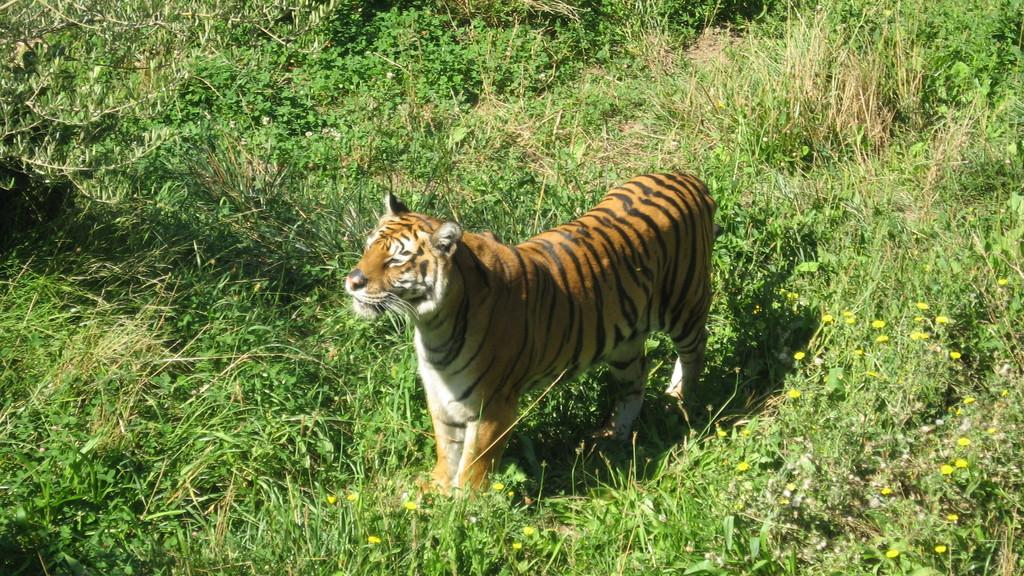What type of animal is in the image? There is a tiger in the image. Where is the tiger located? The tiger is in the grass. What other natural elements can be seen in the image? There are flowers and plants in the image. What type of hole can be seen in the image? There is no hole present in the image. Can you see any smoke coming from the tiger in the image? No, there is no smoke visible in the image. 